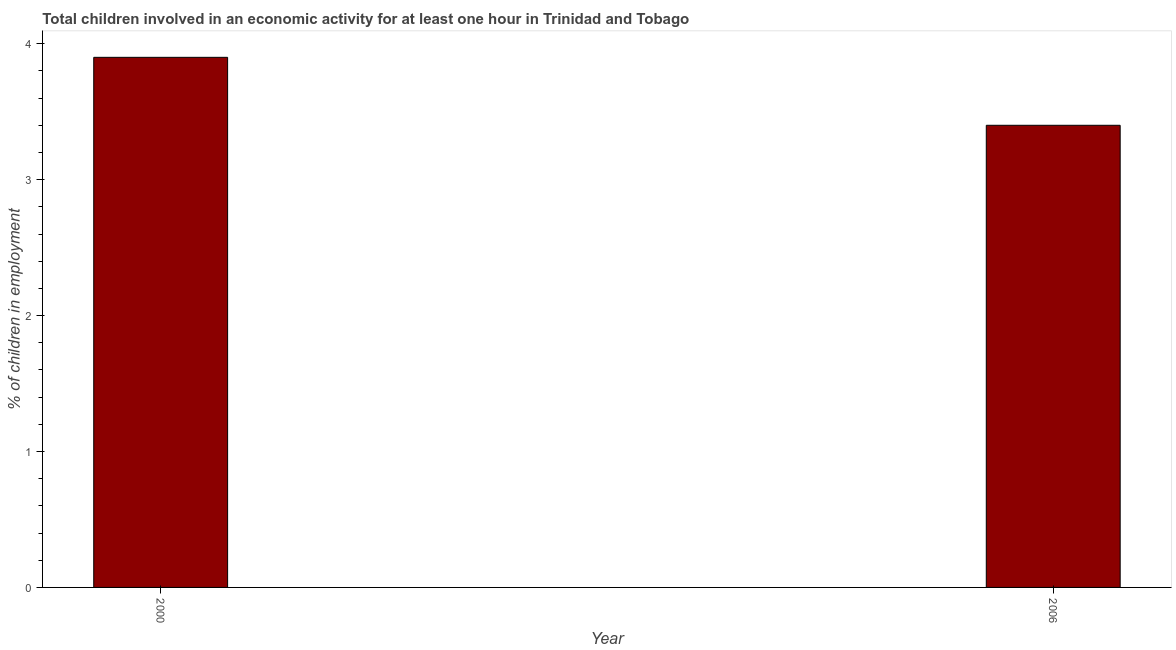Does the graph contain grids?
Offer a very short reply. No. What is the title of the graph?
Your answer should be compact. Total children involved in an economic activity for at least one hour in Trinidad and Tobago. What is the label or title of the X-axis?
Provide a short and direct response. Year. What is the label or title of the Y-axis?
Give a very brief answer. % of children in employment. Across all years, what is the minimum percentage of children in employment?
Offer a very short reply. 3.4. What is the sum of the percentage of children in employment?
Make the answer very short. 7.3. What is the average percentage of children in employment per year?
Your answer should be very brief. 3.65. What is the median percentage of children in employment?
Offer a terse response. 3.65. What is the ratio of the percentage of children in employment in 2000 to that in 2006?
Ensure brevity in your answer.  1.15. Is the percentage of children in employment in 2000 less than that in 2006?
Ensure brevity in your answer.  No. How many bars are there?
Your answer should be compact. 2. What is the difference between two consecutive major ticks on the Y-axis?
Make the answer very short. 1. Are the values on the major ticks of Y-axis written in scientific E-notation?
Make the answer very short. No. What is the % of children in employment in 2000?
Offer a very short reply. 3.9. What is the % of children in employment in 2006?
Make the answer very short. 3.4. What is the ratio of the % of children in employment in 2000 to that in 2006?
Provide a short and direct response. 1.15. 